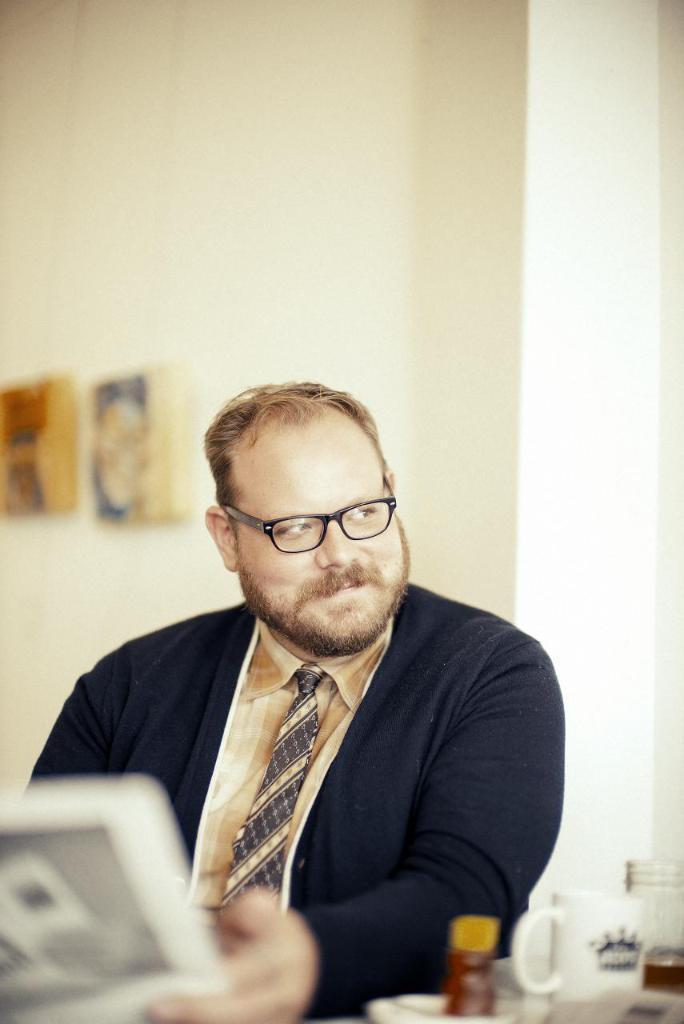Could you give a brief overview of what you see in this image? In the center of the image we can see a person is smiling and he is in a different costume. And we can see he is holding some object and he is wearing glasses. On the right side of the image, we can see some objects. In the background there is a wall and a few other objects. 